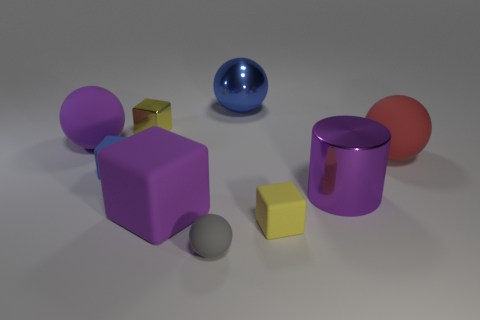There is a yellow object that is to the right of the tiny metal object; is it the same size as the purple thing that is to the right of the blue sphere?
Keep it short and to the point. No. The gray thing is what shape?
Provide a succinct answer. Sphere. What is the size of the metal cylinder that is the same color as the big matte cube?
Provide a succinct answer. Large. The other small sphere that is the same material as the red sphere is what color?
Offer a very short reply. Gray. Is the tiny gray sphere made of the same material as the big purple thing behind the red rubber thing?
Offer a very short reply. Yes. What color is the small metallic block?
Your answer should be very brief. Yellow. There is a blue object that is made of the same material as the purple cylinder; what size is it?
Keep it short and to the point. Large. There is a large purple matte thing that is in front of the large rubber thing that is right of the blue metal thing; what number of big purple objects are in front of it?
Make the answer very short. 0. There is a big metal sphere; is it the same color as the large sphere right of the large blue metallic ball?
Provide a short and direct response. No. There is a big matte thing that is the same color as the big cube; what shape is it?
Provide a succinct answer. Sphere. 